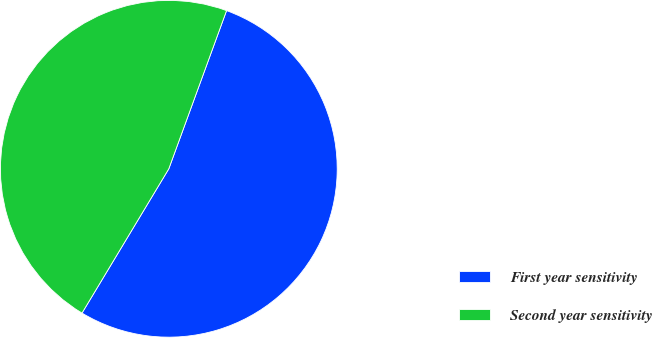Convert chart. <chart><loc_0><loc_0><loc_500><loc_500><pie_chart><fcel>First year sensitivity<fcel>Second year sensitivity<nl><fcel>53.05%<fcel>46.95%<nl></chart> 